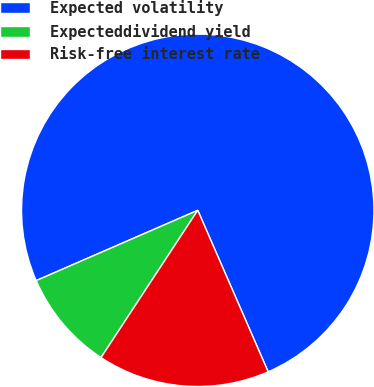Convert chart. <chart><loc_0><loc_0><loc_500><loc_500><pie_chart><fcel>Expected volatility<fcel>Expecteddividend yield<fcel>Risk-free interest rate<nl><fcel>74.99%<fcel>9.22%<fcel>15.79%<nl></chart> 